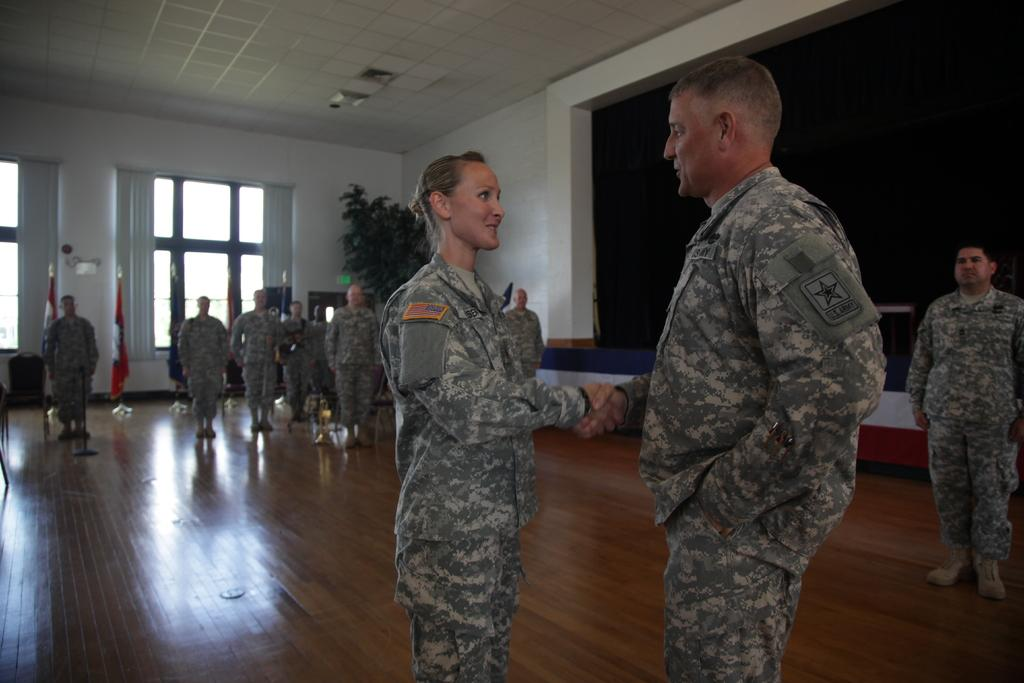What is the main subject of the image? There is a beautiful woman in the image. What is the woman doing in the image? The woman is shaking hands with a man. What type of clothing is the woman wearing? The woman is wearing an army dress. What can be seen on the left side of the image? There is a group of men on the left side of the image. What are the men in the group doing? The group of men are performing army actions. What sea can be seen in the background of the image? There is no sea visible in the image. Is the woman's aunt present in the image? There is no mention of an aunt in the image. What discovery was made by the group of men in the image? There is no indication of a discovery being made in the image. 